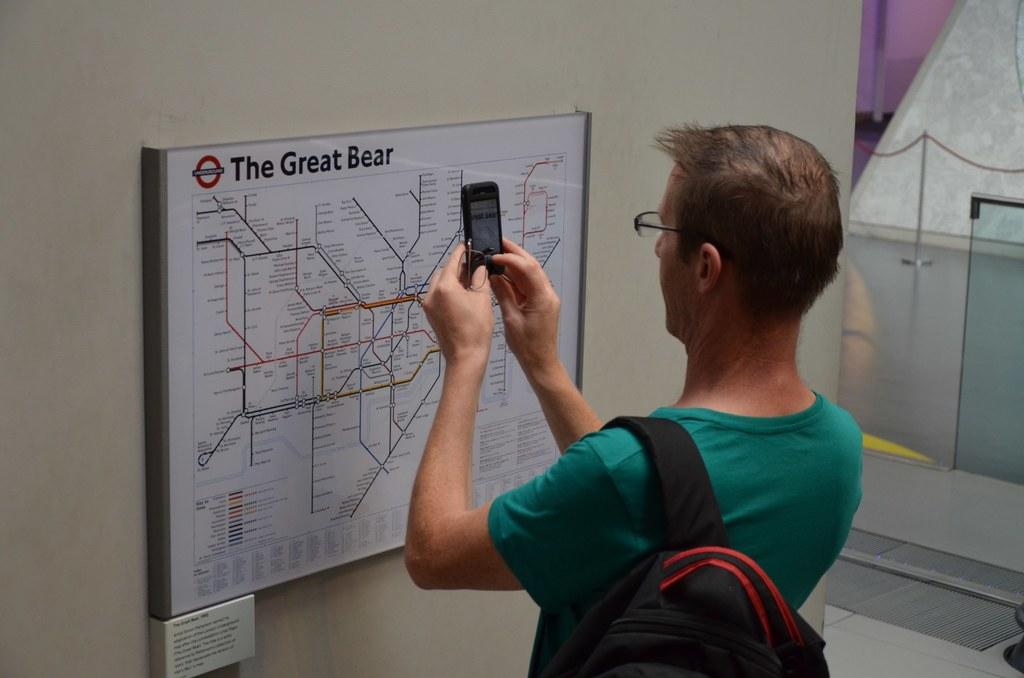What is this man taking a picture of?
Offer a terse response. The great bear. What is the title of the map?
Give a very brief answer. The great bear. 